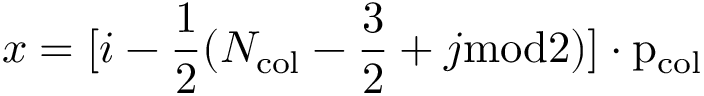Convert formula to latex. <formula><loc_0><loc_0><loc_500><loc_500>x = [ i - \frac { 1 } { 2 } ( N _ { c o l } - \frac { 3 } { 2 } + j { m o d } 2 ) ] \cdot p _ { \mathrm { c o l } }</formula> 